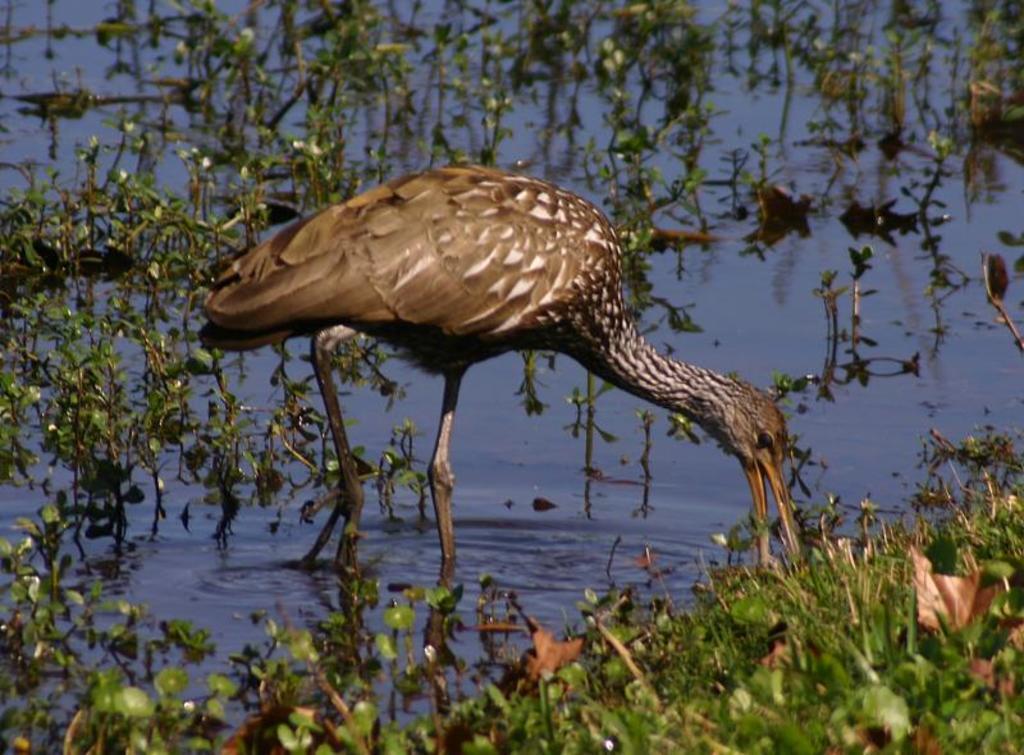How would you summarize this image in a sentence or two? To the bottom of the image there are many plants on the water. In the middle of the water there is a brown crane standing and eating the plants. 